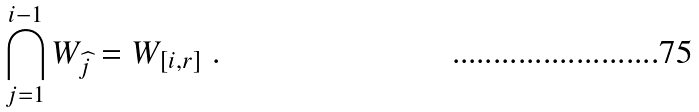<formula> <loc_0><loc_0><loc_500><loc_500>\bigcap _ { j = 1 } ^ { i - 1 } W _ { \widehat { j } } = W _ { [ i , r ] } \ .</formula> 